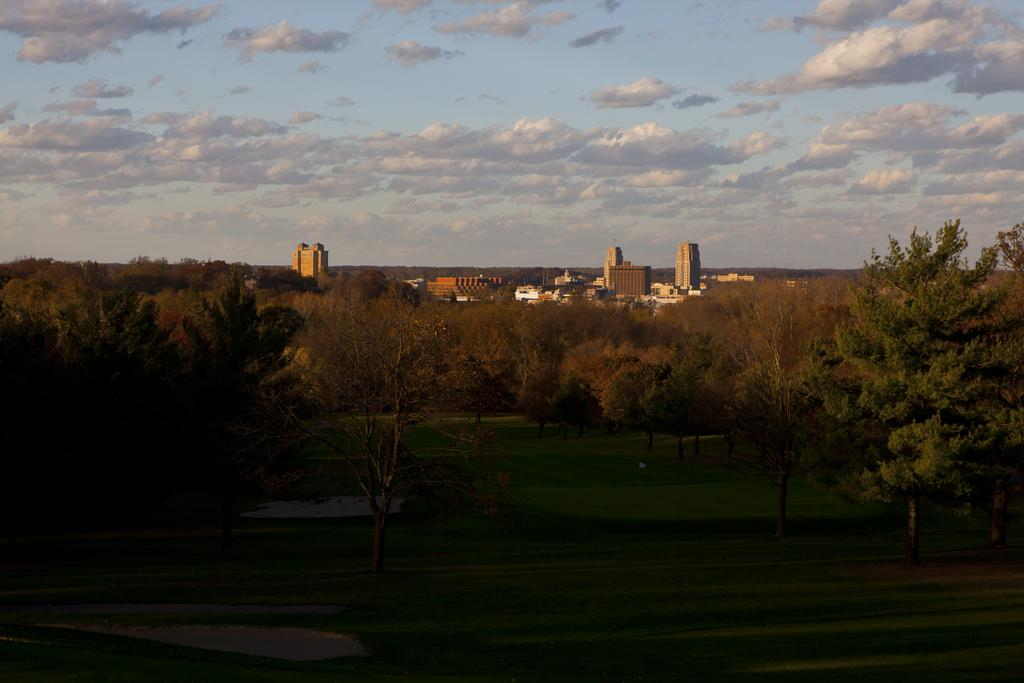What type of vegetation can be seen in the image? There are trees and grass in the image. What type of structures are visible in the image? There are buildings in the image. What part of the natural environment is visible in the image? The sky is visible in the image. Can you describe the setting of the image? The image may have been taken near a farm, as suggested by the presence of trees, grass, and buildings. What type of shirt is the pipe wearing in the image? There is no pipe or shirt present in the image. 